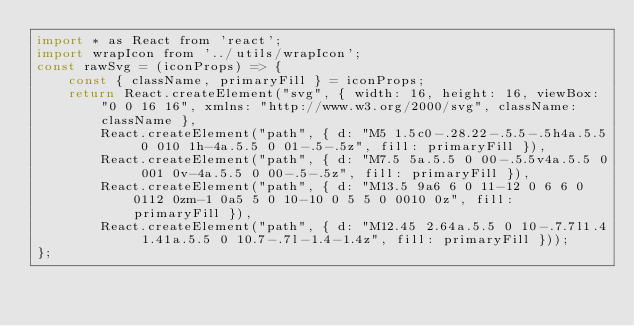Convert code to text. <code><loc_0><loc_0><loc_500><loc_500><_JavaScript_>import * as React from 'react';
import wrapIcon from '../utils/wrapIcon';
const rawSvg = (iconProps) => {
    const { className, primaryFill } = iconProps;
    return React.createElement("svg", { width: 16, height: 16, viewBox: "0 0 16 16", xmlns: "http://www.w3.org/2000/svg", className: className },
        React.createElement("path", { d: "M5 1.5c0-.28.22-.5.5-.5h4a.5.5 0 010 1h-4a.5.5 0 01-.5-.5z", fill: primaryFill }),
        React.createElement("path", { d: "M7.5 5a.5.5 0 00-.5.5v4a.5.5 0 001 0v-4a.5.5 0 00-.5-.5z", fill: primaryFill }),
        React.createElement("path", { d: "M13.5 9a6 6 0 11-12 0 6 6 0 0112 0zm-1 0a5 5 0 10-10 0 5 5 0 0010 0z", fill: primaryFill }),
        React.createElement("path", { d: "M12.45 2.64a.5.5 0 10-.7.7l1.4 1.41a.5.5 0 10.7-.7l-1.4-1.4z", fill: primaryFill }));
};</code> 